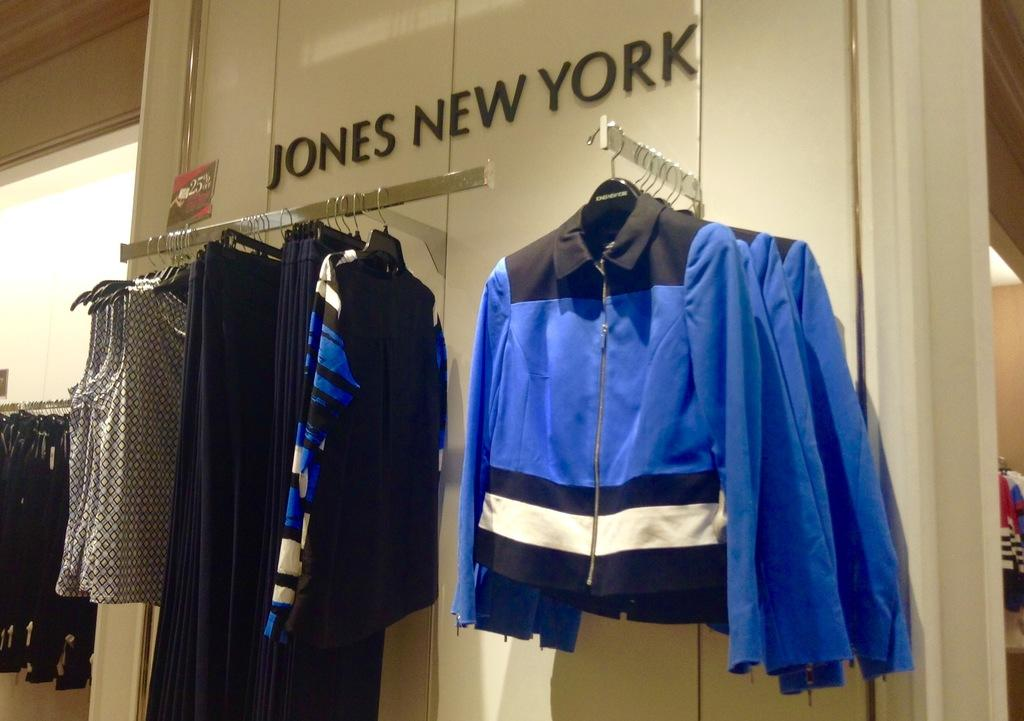<image>
Create a compact narrative representing the image presented. Jones New York sells different types of articles of clothes. 